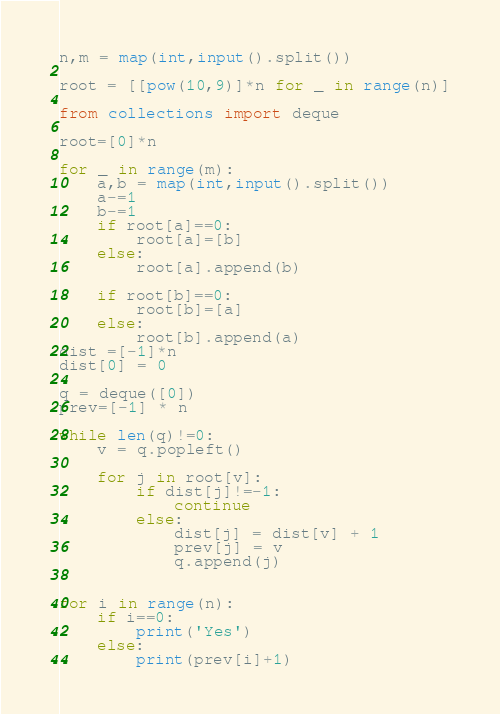<code> <loc_0><loc_0><loc_500><loc_500><_Python_>n,m = map(int,input().split())

root = [[pow(10,9)]*n for _ in range(n)]

from collections import deque

root=[0]*n

for _ in range(m):
    a,b = map(int,input().split())
    a-=1
    b-=1
    if root[a]==0:
        root[a]=[b]
    else:
        root[a].append(b)

    if root[b]==0:
        root[b]=[a]
    else:
        root[b].append(a)
dist =[-1]*n
dist[0] = 0

q = deque([0])
prev=[-1] * n

while len(q)!=0:
    v = q.popleft()

    for j in root[v]:
        if dist[j]!=-1:
            continue
        else:
            dist[j] = dist[v] + 1
            prev[j] = v
            q.append(j)


for i in range(n):
    if i==0:
        print('Yes')
    else:
        print(prev[i]+1)
</code> 